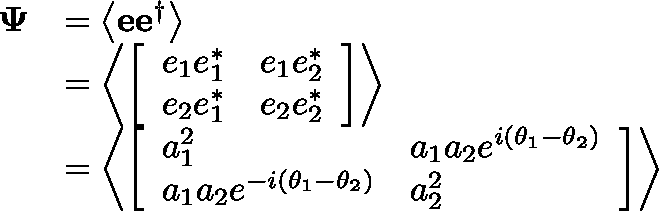Convert formula to latex. <formula><loc_0><loc_0><loc_500><loc_500>{ \begin{array} { r l } { \Psi } & { = \left \langle e e ^ { \dagger } \right \rangle } \\ & { = \left \langle { \left [ \begin{array} { l l } { e _ { 1 } e _ { 1 } ^ { * } } & { e _ { 1 } e _ { 2 } ^ { * } } \\ { e _ { 2 } e _ { 1 } ^ { * } } & { e _ { 2 } e _ { 2 } ^ { * } } \end{array} \right ] } \right \rangle } \\ & { = \left \langle { \left [ \begin{array} { l l } { a _ { 1 } ^ { 2 } } & { a _ { 1 } a _ { 2 } e ^ { i \left ( \theta _ { 1 } - \theta _ { 2 } \right ) } } \\ { a _ { 1 } a _ { 2 } e ^ { - i \left ( \theta _ { 1 } - \theta _ { 2 } \right ) } } & { a _ { 2 } ^ { 2 } } \end{array} \right ] } \right \rangle } \end{array} }</formula> 